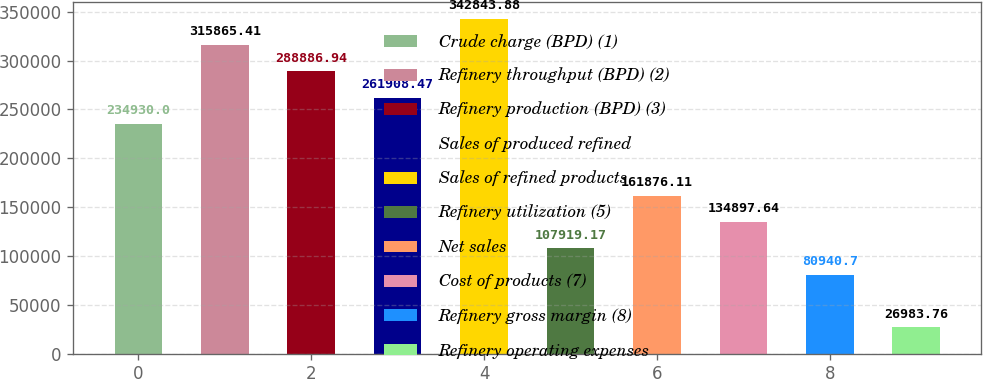<chart> <loc_0><loc_0><loc_500><loc_500><bar_chart><fcel>Crude charge (BPD) (1)<fcel>Refinery throughput (BPD) (2)<fcel>Refinery production (BPD) (3)<fcel>Sales of produced refined<fcel>Sales of refined products<fcel>Refinery utilization (5)<fcel>Net sales<fcel>Cost of products (7)<fcel>Refinery gross margin (8)<fcel>Refinery operating expenses<nl><fcel>234930<fcel>315865<fcel>288887<fcel>261908<fcel>342844<fcel>107919<fcel>161876<fcel>134898<fcel>80940.7<fcel>26983.8<nl></chart> 